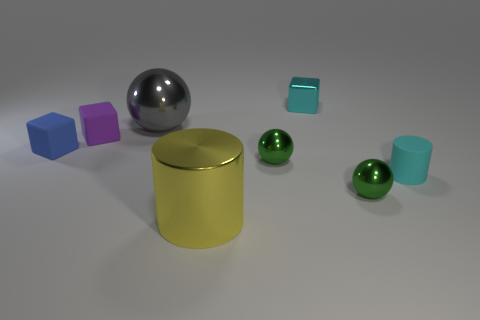Do the gray object that is on the left side of the cyan rubber object and the big yellow metallic object have the same size?
Offer a very short reply. Yes. What number of spheres are blue things or tiny shiny things?
Provide a short and direct response. 2. What material is the ball to the right of the small cyan cube?
Your response must be concise. Metal. Is the number of small green spheres less than the number of tiny cubes?
Your answer should be compact. Yes. There is a metallic thing that is on the left side of the shiny block and behind the blue matte block; what size is it?
Offer a terse response. Large. What is the size of the green metal sphere that is behind the cylinder that is on the right side of the small cube that is right of the large cylinder?
Offer a terse response. Small. What number of other things are there of the same color as the matte cylinder?
Your answer should be compact. 1. Does the small block behind the purple block have the same color as the tiny rubber cylinder?
Provide a short and direct response. Yes. How many objects are either green objects or large yellow cylinders?
Keep it short and to the point. 3. There is a small object behind the gray sphere; what is its color?
Keep it short and to the point. Cyan. 